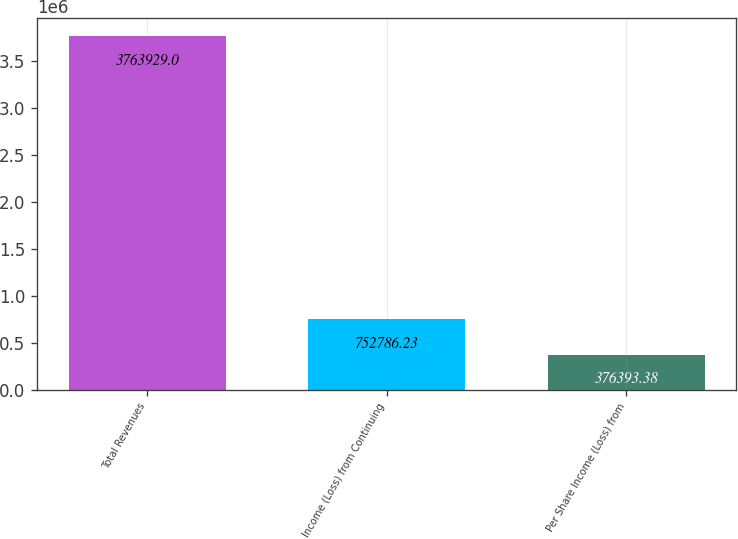<chart> <loc_0><loc_0><loc_500><loc_500><bar_chart><fcel>Total Revenues<fcel>Income (Loss) from Continuing<fcel>Per Share Income (Loss) from<nl><fcel>3.76393e+06<fcel>752786<fcel>376393<nl></chart> 